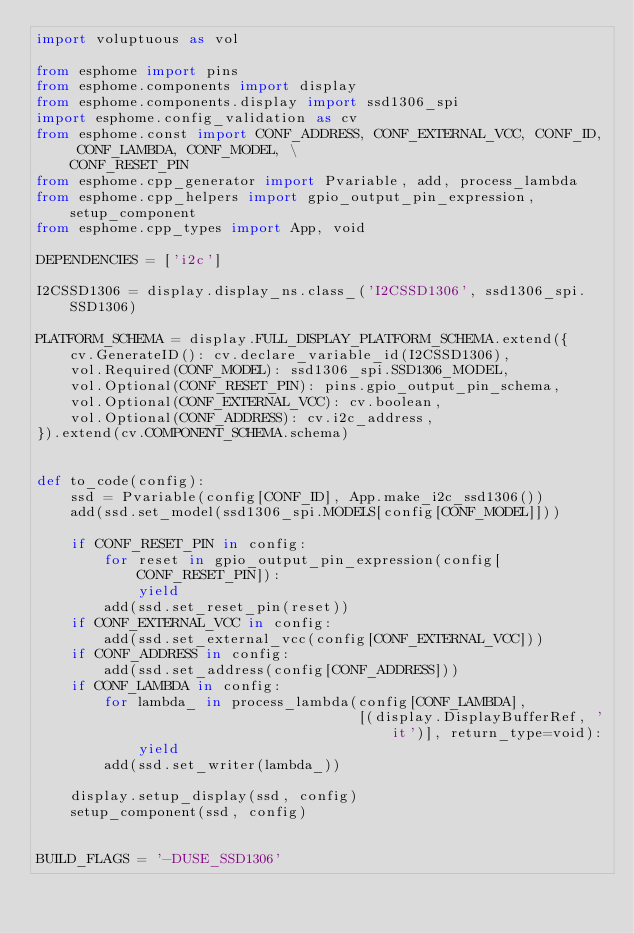Convert code to text. <code><loc_0><loc_0><loc_500><loc_500><_Python_>import voluptuous as vol

from esphome import pins
from esphome.components import display
from esphome.components.display import ssd1306_spi
import esphome.config_validation as cv
from esphome.const import CONF_ADDRESS, CONF_EXTERNAL_VCC, CONF_ID, CONF_LAMBDA, CONF_MODEL, \
    CONF_RESET_PIN
from esphome.cpp_generator import Pvariable, add, process_lambda
from esphome.cpp_helpers import gpio_output_pin_expression, setup_component
from esphome.cpp_types import App, void

DEPENDENCIES = ['i2c']

I2CSSD1306 = display.display_ns.class_('I2CSSD1306', ssd1306_spi.SSD1306)

PLATFORM_SCHEMA = display.FULL_DISPLAY_PLATFORM_SCHEMA.extend({
    cv.GenerateID(): cv.declare_variable_id(I2CSSD1306),
    vol.Required(CONF_MODEL): ssd1306_spi.SSD1306_MODEL,
    vol.Optional(CONF_RESET_PIN): pins.gpio_output_pin_schema,
    vol.Optional(CONF_EXTERNAL_VCC): cv.boolean,
    vol.Optional(CONF_ADDRESS): cv.i2c_address,
}).extend(cv.COMPONENT_SCHEMA.schema)


def to_code(config):
    ssd = Pvariable(config[CONF_ID], App.make_i2c_ssd1306())
    add(ssd.set_model(ssd1306_spi.MODELS[config[CONF_MODEL]]))

    if CONF_RESET_PIN in config:
        for reset in gpio_output_pin_expression(config[CONF_RESET_PIN]):
            yield
        add(ssd.set_reset_pin(reset))
    if CONF_EXTERNAL_VCC in config:
        add(ssd.set_external_vcc(config[CONF_EXTERNAL_VCC]))
    if CONF_ADDRESS in config:
        add(ssd.set_address(config[CONF_ADDRESS]))
    if CONF_LAMBDA in config:
        for lambda_ in process_lambda(config[CONF_LAMBDA],
                                      [(display.DisplayBufferRef, 'it')], return_type=void):
            yield
        add(ssd.set_writer(lambda_))

    display.setup_display(ssd, config)
    setup_component(ssd, config)


BUILD_FLAGS = '-DUSE_SSD1306'
</code> 